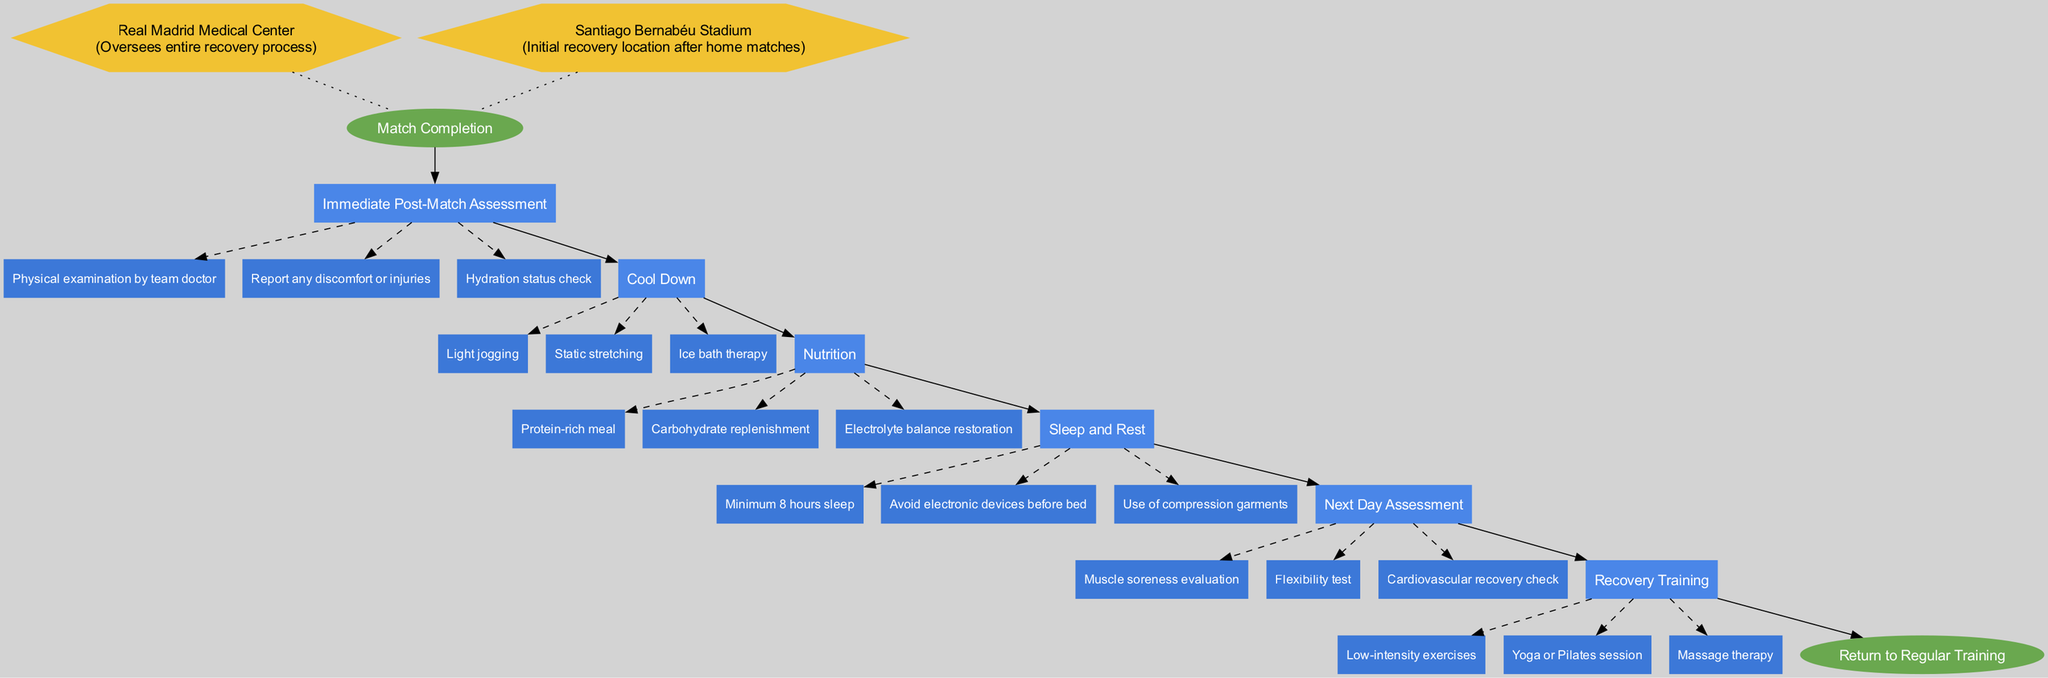What is the starting point of the clinical pathway? The starting point is "Match Completion," which indicates when the process begins after a match has concluded. This is the initial node in the diagram.
Answer: Match Completion How many steps are included in the clinical pathway? There are a total of six steps listed in the pathway that detail the processes undertaken after a match. Each step is represented individually in the diagram.
Answer: 6 What type of assessment occurs immediately after the match? The first step is focused on performing an "Immediate Post-Match Assessment," which refers to an evaluation performed right after the match.
Answer: Immediate Post-Match Assessment Which step involves nutrition-related activities? The step specifically focused on nutrition is titled "Nutrition," indicating the phase where dietary actions are taken to aid recovery.
Answer: Nutrition What activity is included in the 'Cool Down' step? One of the activities included in the "Cool Down" step is "Ice bath therapy," which is a common practice to help reduce muscle soreness.
Answer: Ice bath therapy What is the minimum sleep duration recommended in the 'Sleep and Rest' step? The 'Sleep and Rest' step recommends a minimum of "8 hours sleep," emphasizing the importance of rest for recovery.
Answer: 8 hours How does the clinical pathway conclude? The clinical pathway concludes with the "Return to Regular Training," which signifies the completion of the recovery process and readiness to resume normal training activities.
Answer: Return to Regular Training Which location is mentioned as the initial recovery site after home matches? The "Santiago Bernabéu Stadium" is identified as the initial recovery location for players after home matches have ended.
Answer: Santiago Bernabéu Stadium What type of therapies are included in the 'Recovery Training' step? The 'Recovery Training' step includes "Massage therapy," which is a form of treatment utilized to promote recovery and relaxation.
Answer: Massage therapy 